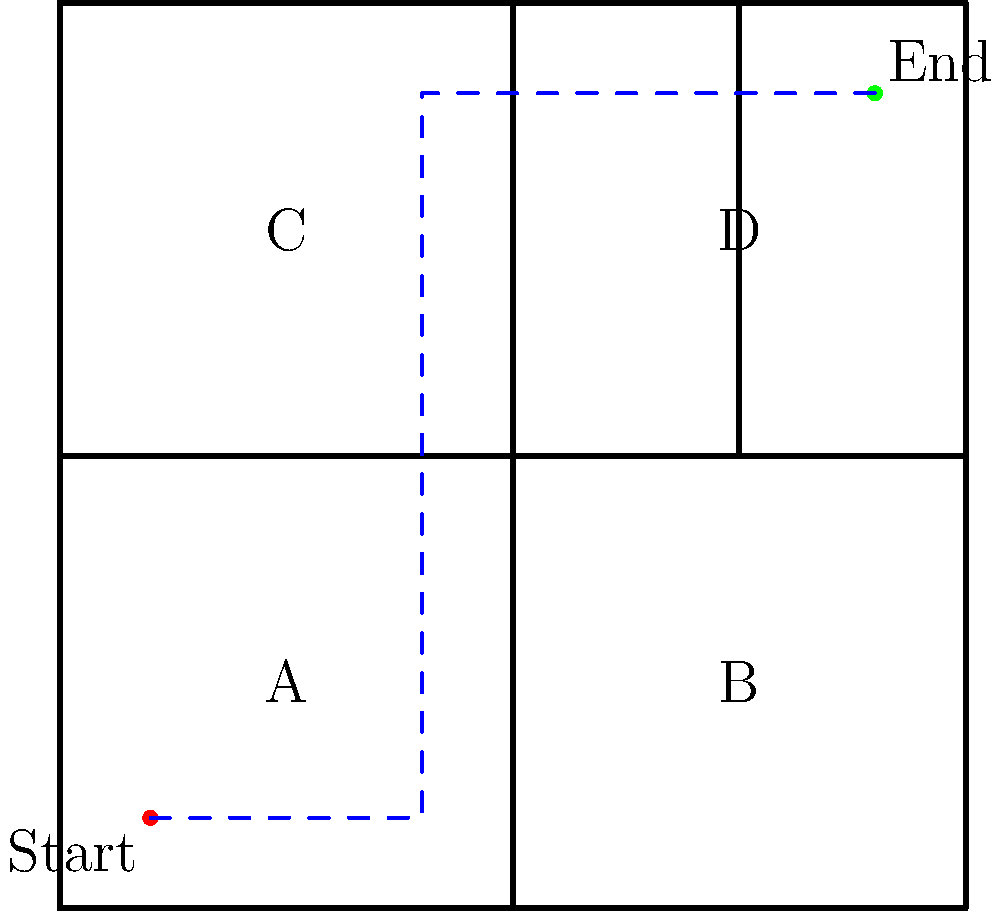As a manager focused on efficiency, you need to navigate through the office layout shown above. What is the shortest path from the Start point to the End point, passing through at least two of the labeled areas (A, B, C, or D)? To find the most efficient path, we need to consider the following steps:

1. Analyze the layout: The office is divided into four quadrants (A, B, C, D) with walls between them.

2. Identify constraints: We must pass through at least two labeled areas while moving from Start to End.

3. Consider possible routes:
   a. Start → A → C → End
   b. Start → A → D → End
   c. Start → B → D → End

4. Evaluate each route:
   a. Start → A → C → End: Requires multiple turns and longer distance.
   b. Start → A → D → End: Most direct path with fewest turns.
   c. Start → B → D → End: Requires backtracking, inefficient.

5. Choose the optimal path: Start → A → D → End
   This path minimizes distance and number of turns while meeting the requirement of passing through two labeled areas.

6. Describe the path:
   - Move east from Start to the edge of area A
   - Go north to the top of the office
   - Move east to reach the End point

This route optimizes for efficiency by minimizing distance and turns while adhering to the given constraints.
Answer: Start → A → D → End 